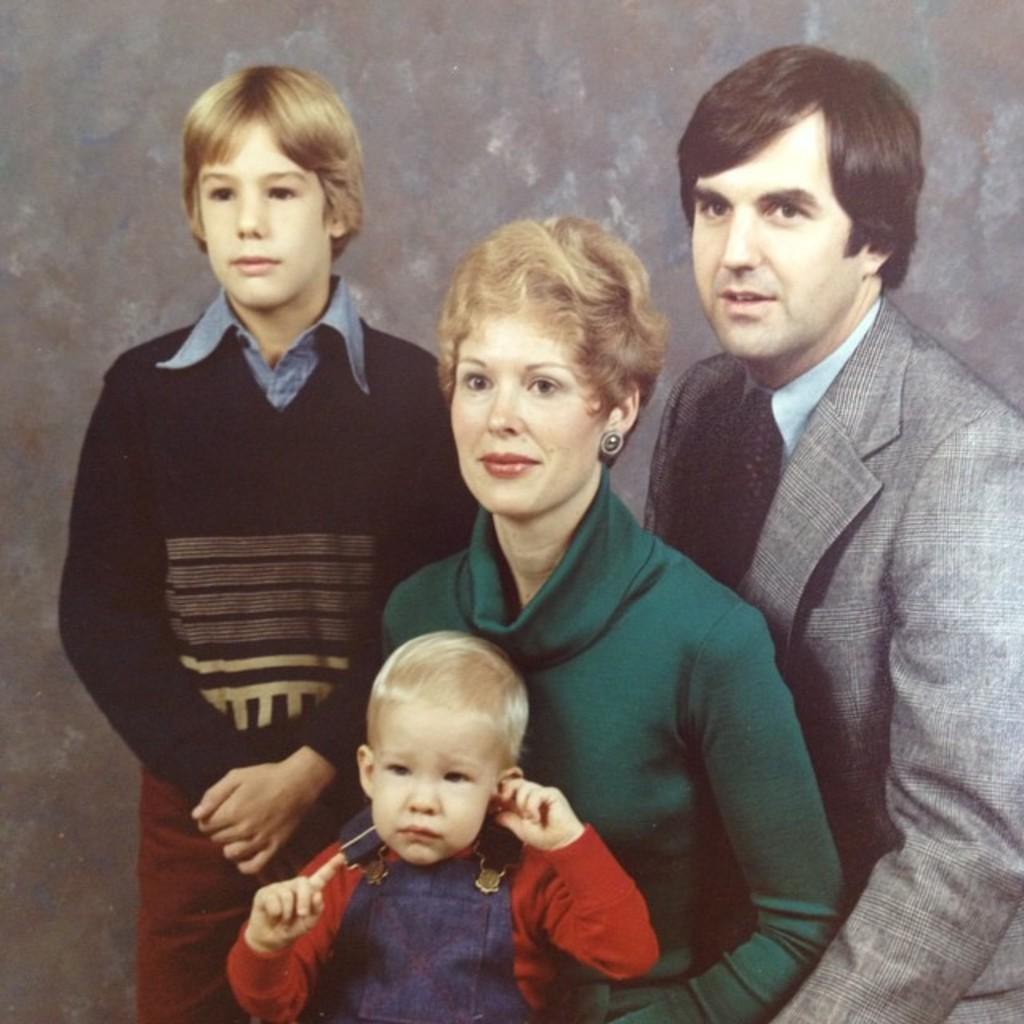What is the main subject of the image? The main subject of the image is a group of people. Can you describe the woman in the image? Yes, there is a woman in the middle of the image, and she is wearing a green dress. What type of chess piece is the woman holding in the image? There is no chess piece present in the image. Can you tell me where the map is located in the image? There is no map present in the image. 